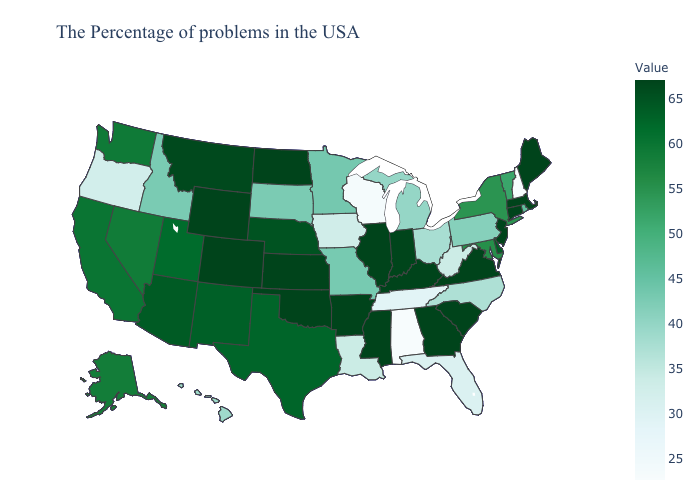Is the legend a continuous bar?
Answer briefly. Yes. Does the map have missing data?
Answer briefly. No. Is the legend a continuous bar?
Short answer required. Yes. Does Wisconsin have the highest value in the USA?
Give a very brief answer. No. 